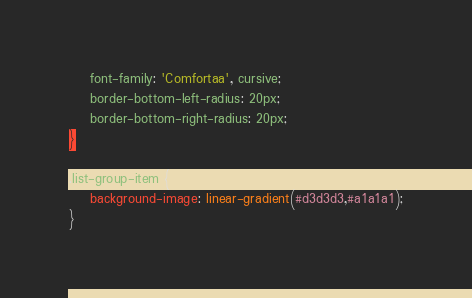Convert code to text. <code><loc_0><loc_0><loc_500><loc_500><_CSS_>	font-family: 'Comfortaa', cursive;
	border-bottom-left-radius: 20px;
	border-bottom-right-radius: 20px;
}

.list-group-item {
	background-image: linear-gradient(#d3d3d3,#a1a1a1);
}


</code> 